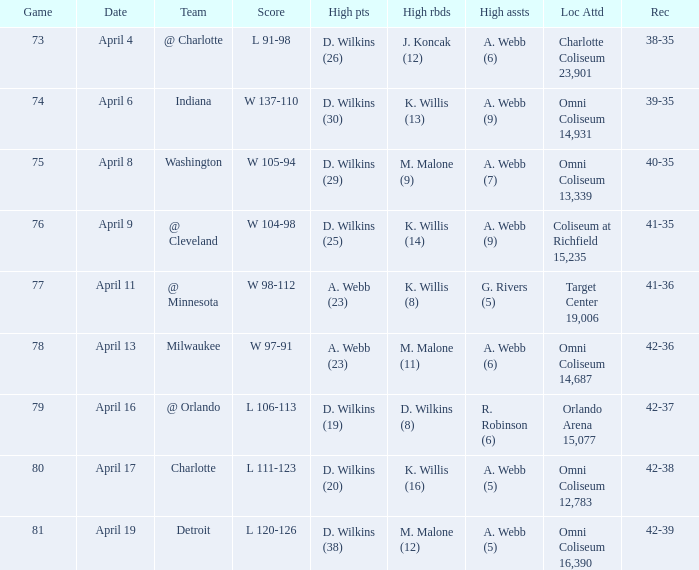What was the location and attendance when d. wilkins (29) had the high points? Omni Coliseum 13,339. 